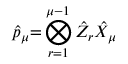Convert formula to latex. <formula><loc_0><loc_0><loc_500><loc_500>\hat { p } _ { \mu } { = } \bigotimes _ { r = 1 } ^ { \mu - 1 } \hat { Z } _ { r } \hat { X } _ { \mu }</formula> 